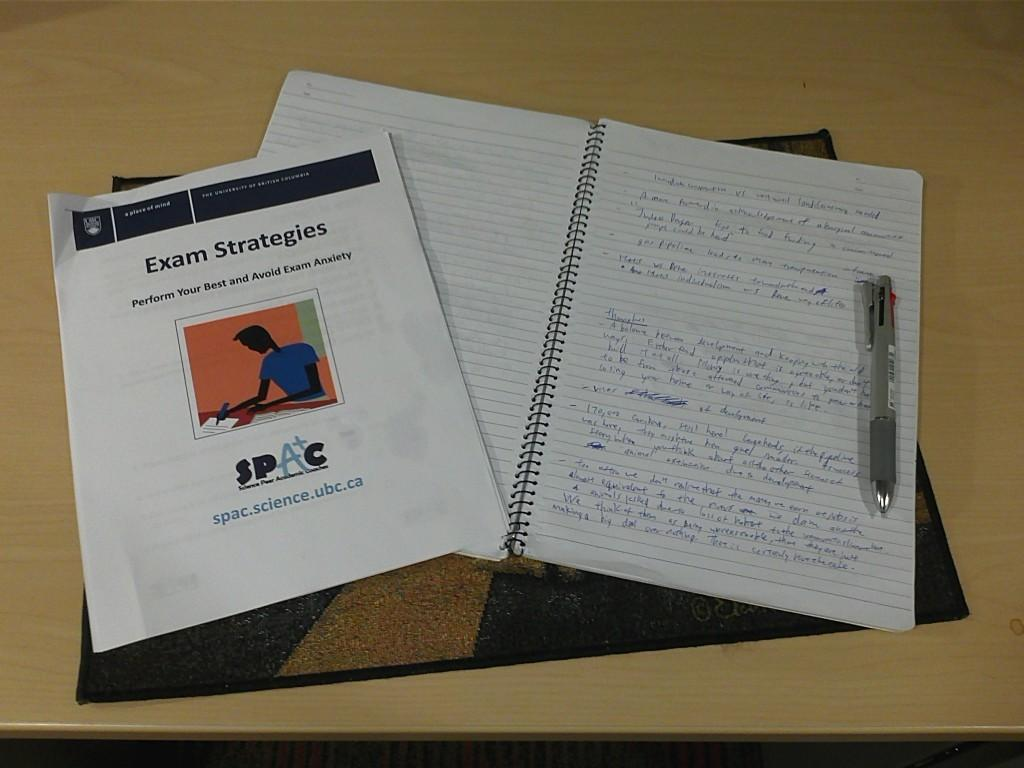<image>
Render a clear and concise summary of the photo. a printed page with the title exam strategies with an open notebook on the side. 